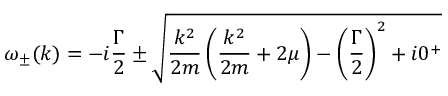<formula> <loc_0><loc_0><loc_500><loc_500>\omega _ { \pm } ( k ) = - i \frac { \Gamma } { 2 } \pm \sqrt { \frac { k ^ { 2 } } { 2 m } \left ( \frac { k ^ { 2 } } { 2 m } + 2 \mu \right ) - \left ( \frac { \Gamma } { 2 } \right ) ^ { 2 } + i 0 ^ { + } }</formula> 